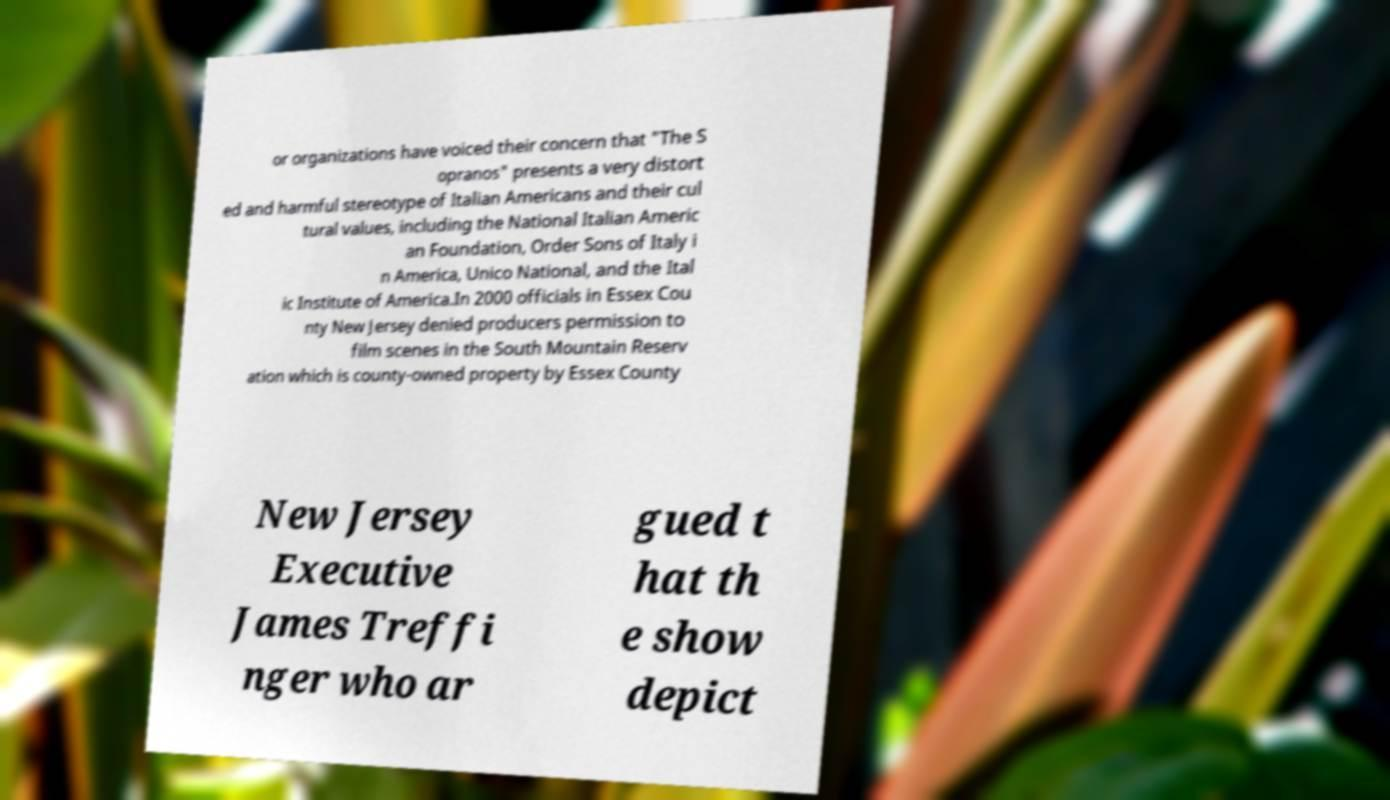Could you assist in decoding the text presented in this image and type it out clearly? or organizations have voiced their concern that "The S opranos" presents a very distort ed and harmful stereotype of Italian Americans and their cul tural values, including the National Italian Americ an Foundation, Order Sons of Italy i n America, Unico National, and the Ital ic Institute of America.In 2000 officials in Essex Cou nty New Jersey denied producers permission to film scenes in the South Mountain Reserv ation which is county-owned property by Essex County New Jersey Executive James Treffi nger who ar gued t hat th e show depict 